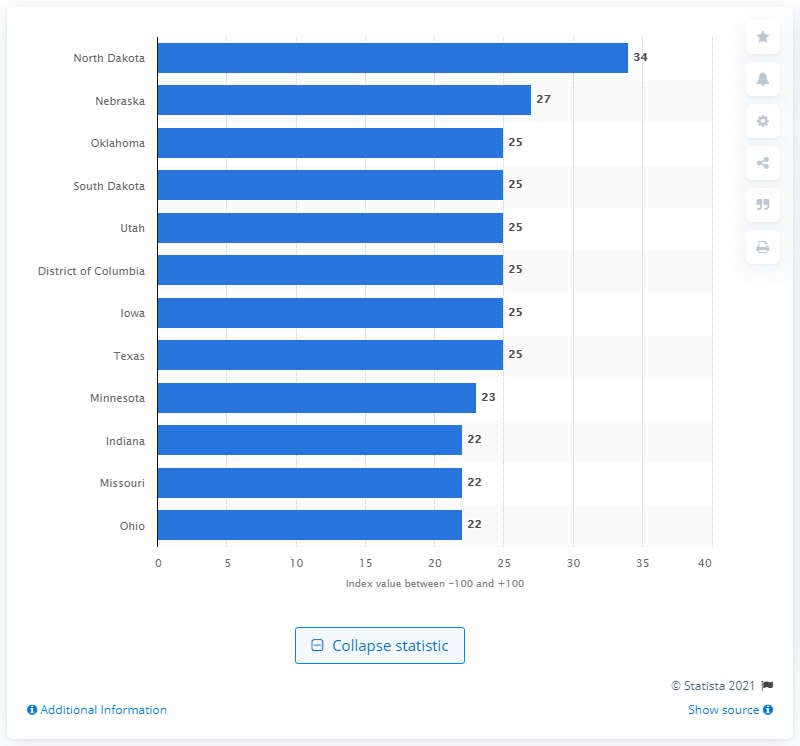List a handful of essential elements in this visual. In the first half of 2012, the Job Creation Index for North Dakota was 34. 